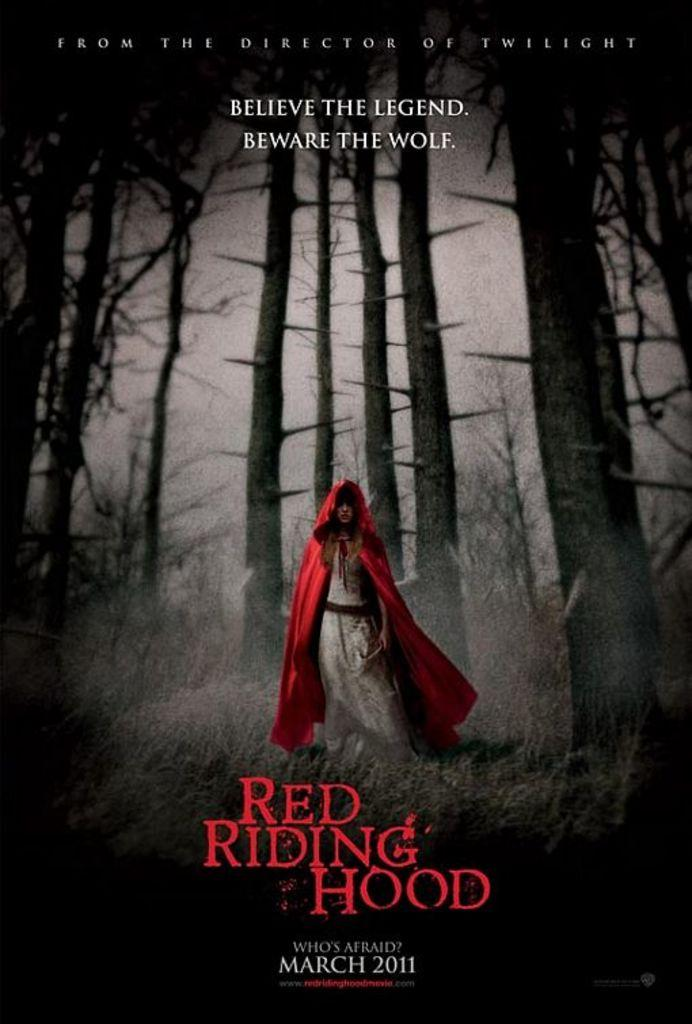<image>
Relay a brief, clear account of the picture shown. The film Red Riding Hood had the director of Twilight at its helm. 